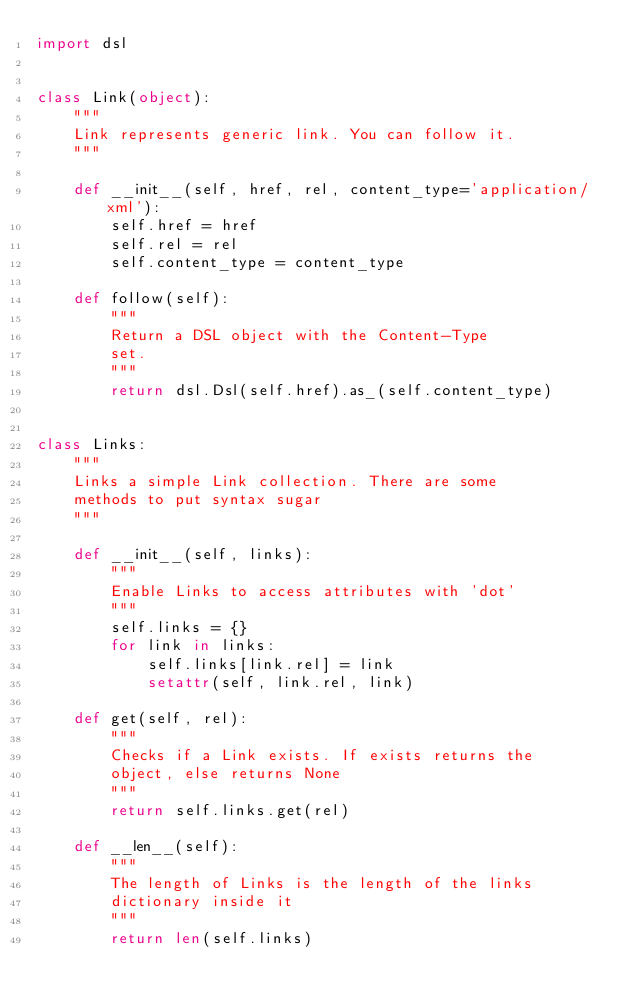<code> <loc_0><loc_0><loc_500><loc_500><_Python_>import dsl


class Link(object):
    """
    Link represents generic link. You can follow it.
    """

    def __init__(self, href, rel, content_type='application/xml'):
        self.href = href
        self.rel = rel
        self.content_type = content_type

    def follow(self):
        """
        Return a DSL object with the Content-Type
        set.
        """
        return dsl.Dsl(self.href).as_(self.content_type)


class Links:
    """
    Links a simple Link collection. There are some
    methods to put syntax sugar
    """

    def __init__(self, links):
        """
        Enable Links to access attributes with 'dot'
        """
        self.links = {}
        for link in links:
            self.links[link.rel] = link
            setattr(self, link.rel, link)

    def get(self, rel):
        """
        Checks if a Link exists. If exists returns the
        object, else returns None
        """
        return self.links.get(rel)

    def __len__(self):
        """
        The length of Links is the length of the links
        dictionary inside it
        """
        return len(self.links)
</code> 